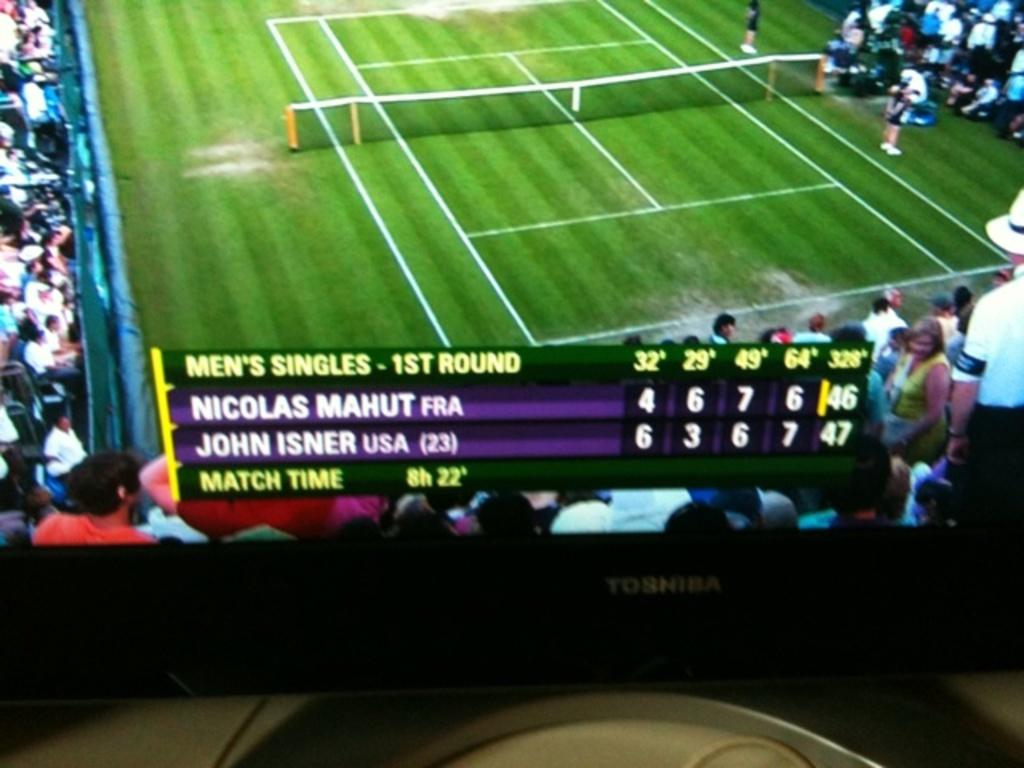Provide a one-sentence caption for the provided image. Nicolas Mahut and John Isner play in the 1st round of Mens Singles. 